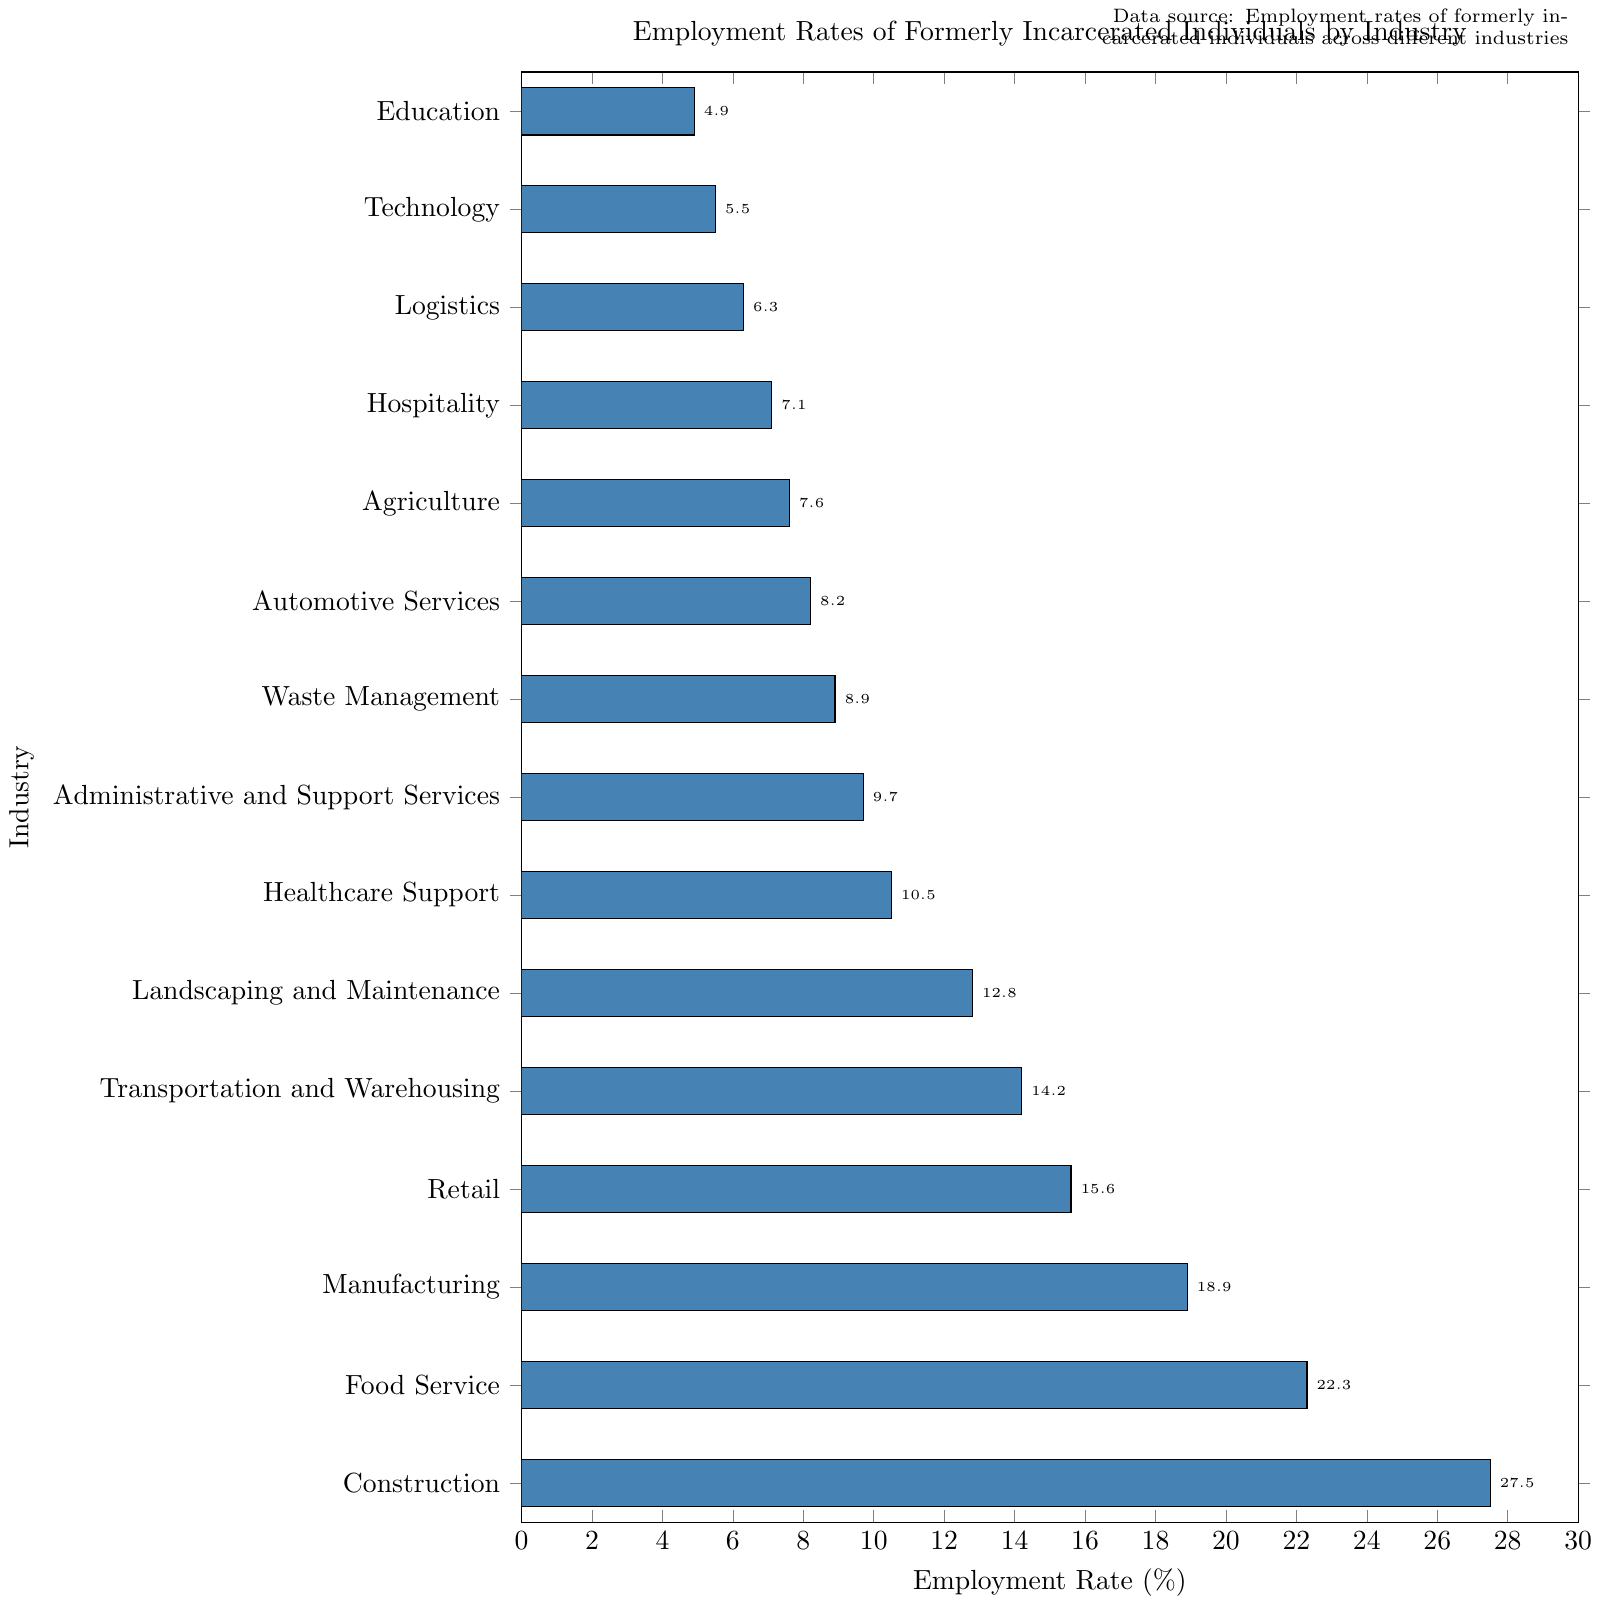Which industry has the highest employment rate for formerly incarcerated individuals? The bar chart shows the employment rates across different industries for formerly incarcerated individuals. The industry with the longest bar has the highest employment rate.
Answer: Construction Which industries have an employment rate greater than 15%? By visually inspecting the bars with lengths corresponding to an employment rate greater than 15%, we see that Construction, Food Service, Manufacturing, and Retail have rates above 15%.
Answer: Construction, Food Service, Manufacturing, Retail How much higher is the employment rate in Construction compared to Technology? The employment rate in Construction is 27.5%, and in Technology, it is 5.5%. Subtracting the employment rate of Technology from Construction gives 27.5% - 5.5%.
Answer: 22% Which industry has the lowest employment rate for formerly incarcerated individuals? The bar with the shortest length represents the industry with the lowest employment rate.
Answer: Arts and Entertainment Calculate the average employment rate of the top three industries. The top three industries by employment rate are Construction (27.5%), Food Service (22.3%), and Manufacturing (18.9%). The average is calculated as (27.5 + 22.3 + 18.9) / 3.
Answer: 22.9% Compare the employment rate in Healthcare Support with Administrative and Support Services. Which one is higher and by how much? Healthcare Support has an employment rate of 10.5%, and Administrative and Support Services has 9.7%. The difference between them is 10.5% - 9.7%.
Answer: Healthcare Support, 0.8% Which industries have an employment rate between 10% and 15%? By examining the bars, we see that Healthcare Support (10.5%), Landscaping and Maintenance (12.8%), and Transportation and Warehousing (14.2%) fall in the range of 10% to 15%.
Answer: Healthcare Support, Landscaping and Maintenance, Transportation and Warehousing List the industries in descending order of employment rates. To arrange the industries, we start with the industry with the highest rate and work down to the one with the lowest rate: Construction, Food Service, Manufacturing, Retail, Transportation and Warehousing, Landscaping and Maintenance, Healthcare Support, Administrative and Support Services, Waste Management, Automotive Services, Agriculture, Hospitality, Cleaning Services, Logistics, Technology, Education, Social Services, Arts and Entertainment.
Answer: Construction, Food Service, Manufacturing, Retail, Transportation and Warehousing, Landscaping and Maintenance, Healthcare Support, Administrative and Support Services, Waste Management, Automotive Services, Agriculture, Hospitality, Cleaning Services, Logistics, Technology, Education, Social Services, Arts and Entertainment What is the combined employment rate for Retail and Manufacturing? The employment rate for Retail is 15.6%, and for Manufacturing, it is 18.9%. Adding these together yields 15.6% + 18.9%.
Answer: 34.5% How many industries have employment rates lower than 10%? By counting the bars that represent employment rates less than 10%, we find that there are 9 industries: Administrative and Support Services, Waste Management, Automotive Services, Agriculture, Hospitality, Cleaning Services, Logistics, Technology, Education, Social Services, Arts and Entertainment.
Answer: 9 